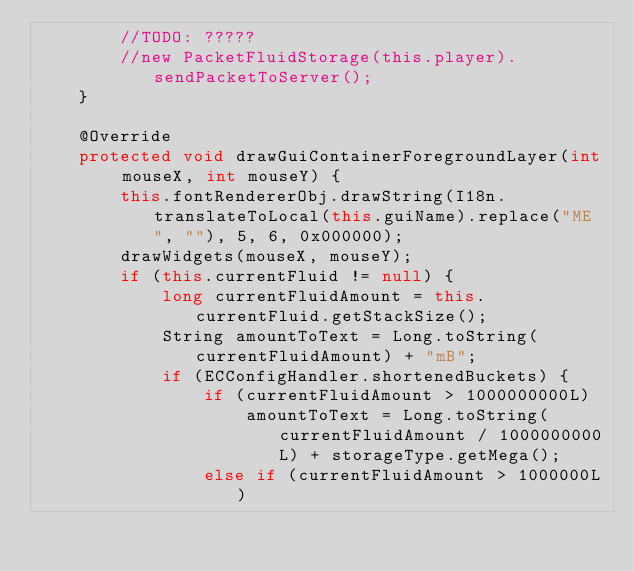Convert code to text. <code><loc_0><loc_0><loc_500><loc_500><_Java_>		//TODO: ?????
		//new PacketFluidStorage(this.player).sendPacketToServer();
	}

	@Override
	protected void drawGuiContainerForegroundLayer(int mouseX, int mouseY) {
		this.fontRendererObj.drawString(I18n.translateToLocal(this.guiName).replace("ME ", ""), 5, 6, 0x000000);
		drawWidgets(mouseX, mouseY);
		if (this.currentFluid != null) {
			long currentFluidAmount = this.currentFluid.getStackSize();
			String amountToText = Long.toString(currentFluidAmount) + "mB";
			if (ECConfigHandler.shortenedBuckets) {
				if (currentFluidAmount > 1000000000L)
					amountToText = Long.toString(currentFluidAmount / 1000000000L) + storageType.getMega();
				else if (currentFluidAmount > 1000000L)</code> 